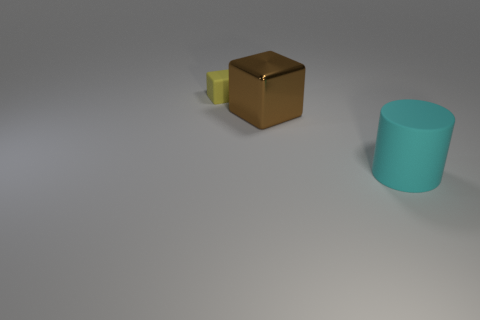Are there any other things that are the same material as the big block?
Provide a succinct answer. No. Are there any other things that have the same size as the yellow cube?
Your answer should be compact. No. There is a cube that is the same size as the cylinder; what is its material?
Offer a very short reply. Metal. What number of green things are either big metallic objects or big rubber cylinders?
Offer a very short reply. 0. There is a object that is in front of the tiny yellow rubber thing and left of the cyan matte thing; what color is it?
Your response must be concise. Brown. Are the large thing in front of the brown metal thing and the block to the left of the large metal cube made of the same material?
Ensure brevity in your answer.  Yes. Are there more big brown cubes in front of the cylinder than small yellow rubber cubes that are in front of the brown thing?
Ensure brevity in your answer.  No. There is a cyan rubber object that is the same size as the metal thing; what shape is it?
Your answer should be very brief. Cylinder. How many objects are either brown objects or large brown metallic cubes that are on the left side of the large cyan cylinder?
Offer a terse response. 1. What number of matte objects are behind the cylinder?
Your answer should be compact. 1. 